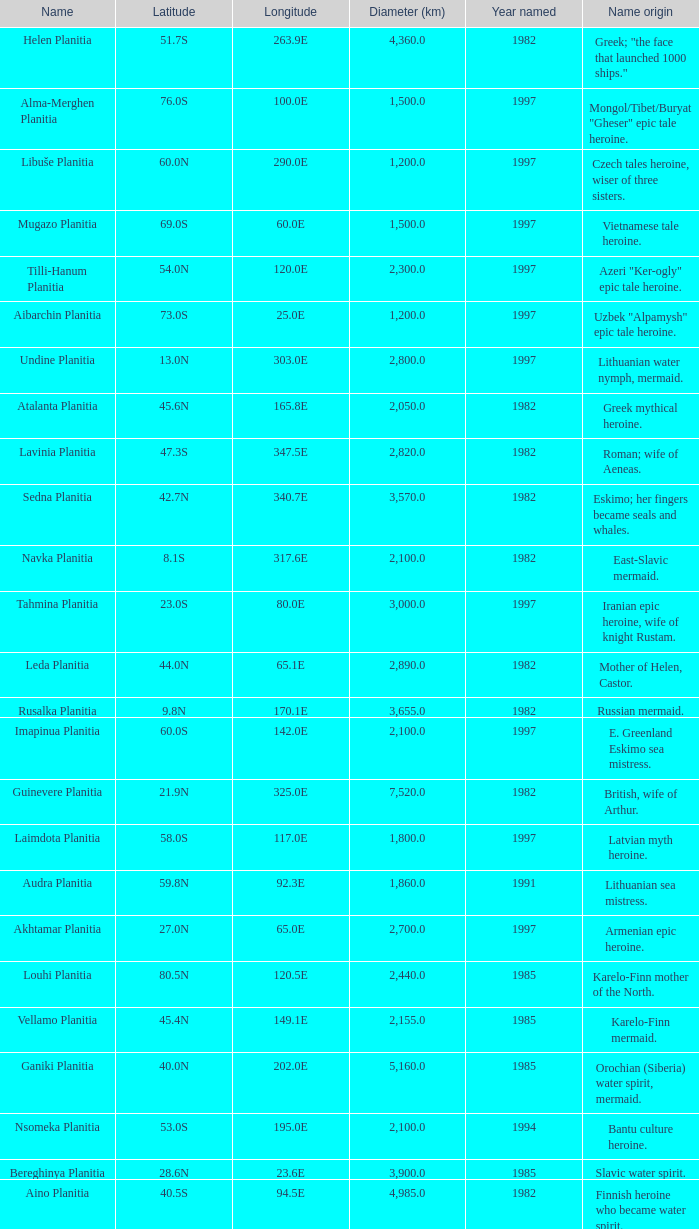What is the diameter (km) of the feature of latitude 23.0s 3000.0. 